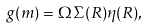Convert formula to latex. <formula><loc_0><loc_0><loc_500><loc_500>g ( m ) = \Omega \Sigma ( R ) \eta ( R ) ,</formula> 